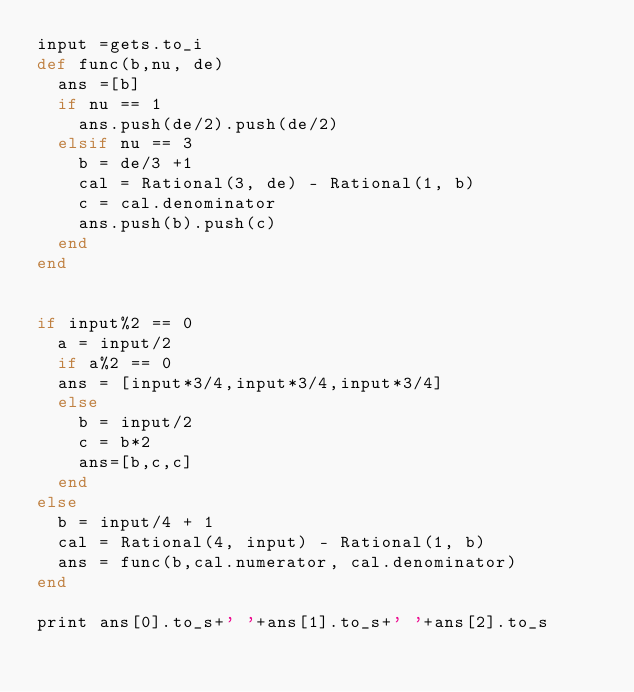<code> <loc_0><loc_0><loc_500><loc_500><_Ruby_>input =gets.to_i
def func(b,nu, de)
  ans =[b]
  if nu == 1
    ans.push(de/2).push(de/2)
  elsif nu == 3
    b = de/3 +1
    cal = Rational(3, de) - Rational(1, b)
    c = cal.denominator
    ans.push(b).push(c)
  end
end


if input%2 == 0
  a = input/2
  if a%2 == 0
  ans = [input*3/4,input*3/4,input*3/4]
  else
    b = input/2
    c = b*2
    ans=[b,c,c]
  end
else
  b = input/4 + 1
  cal = Rational(4, input) - Rational(1, b)
  ans = func(b,cal.numerator, cal.denominator)
end

print ans[0].to_s+' '+ans[1].to_s+' '+ans[2].to_s</code> 